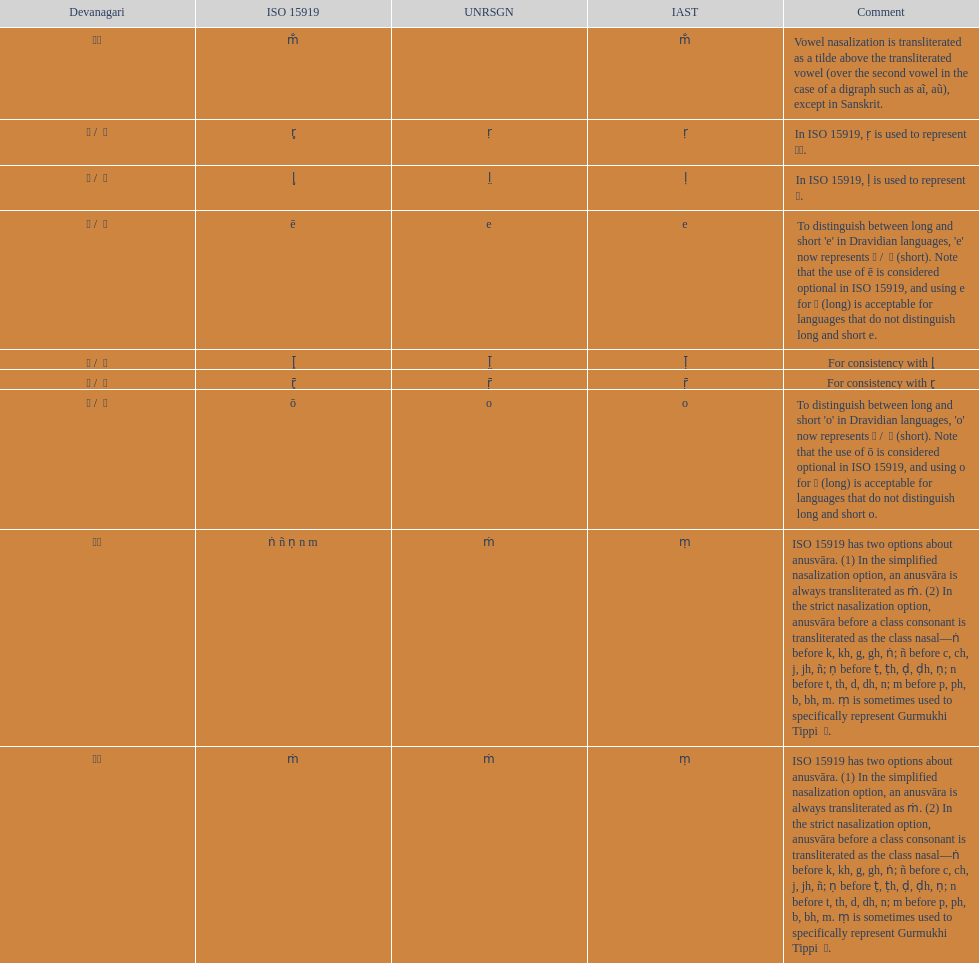Which character is mentioned before the letter 'o' in the term "unrsgn"? E. 